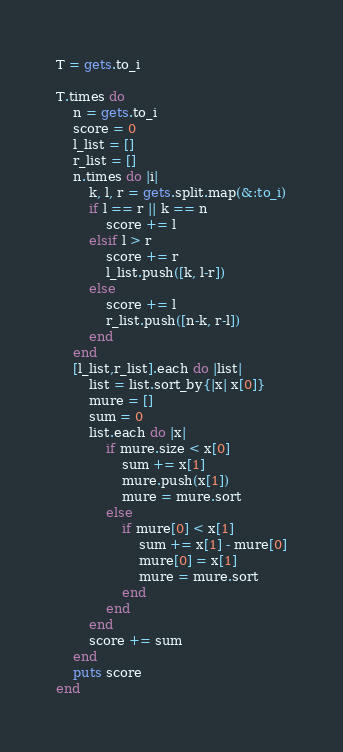Convert code to text. <code><loc_0><loc_0><loc_500><loc_500><_Ruby_>T = gets.to_i

T.times do
    n = gets.to_i
    score = 0
    l_list = []
    r_list = []
    n.times do |i|
        k, l, r = gets.split.map(&:to_i)
        if l == r || k == n
            score += l
        elsif l > r
            score += r
            l_list.push([k, l-r])
        else
            score += l
            r_list.push([n-k, r-l])
        end
    end
    [l_list,r_list].each do |list|
        list = list.sort_by{|x| x[0]}
        mure = []
        sum = 0
        list.each do |x|
            if mure.size < x[0]
                sum += x[1]
                mure.push(x[1])
                mure = mure.sort
            else
                if mure[0] < x[1]
                    sum += x[1] - mure[0]
                    mure[0] = x[1]
                    mure = mure.sort
                end
            end
        end
        score += sum
    end
    puts score
end</code> 